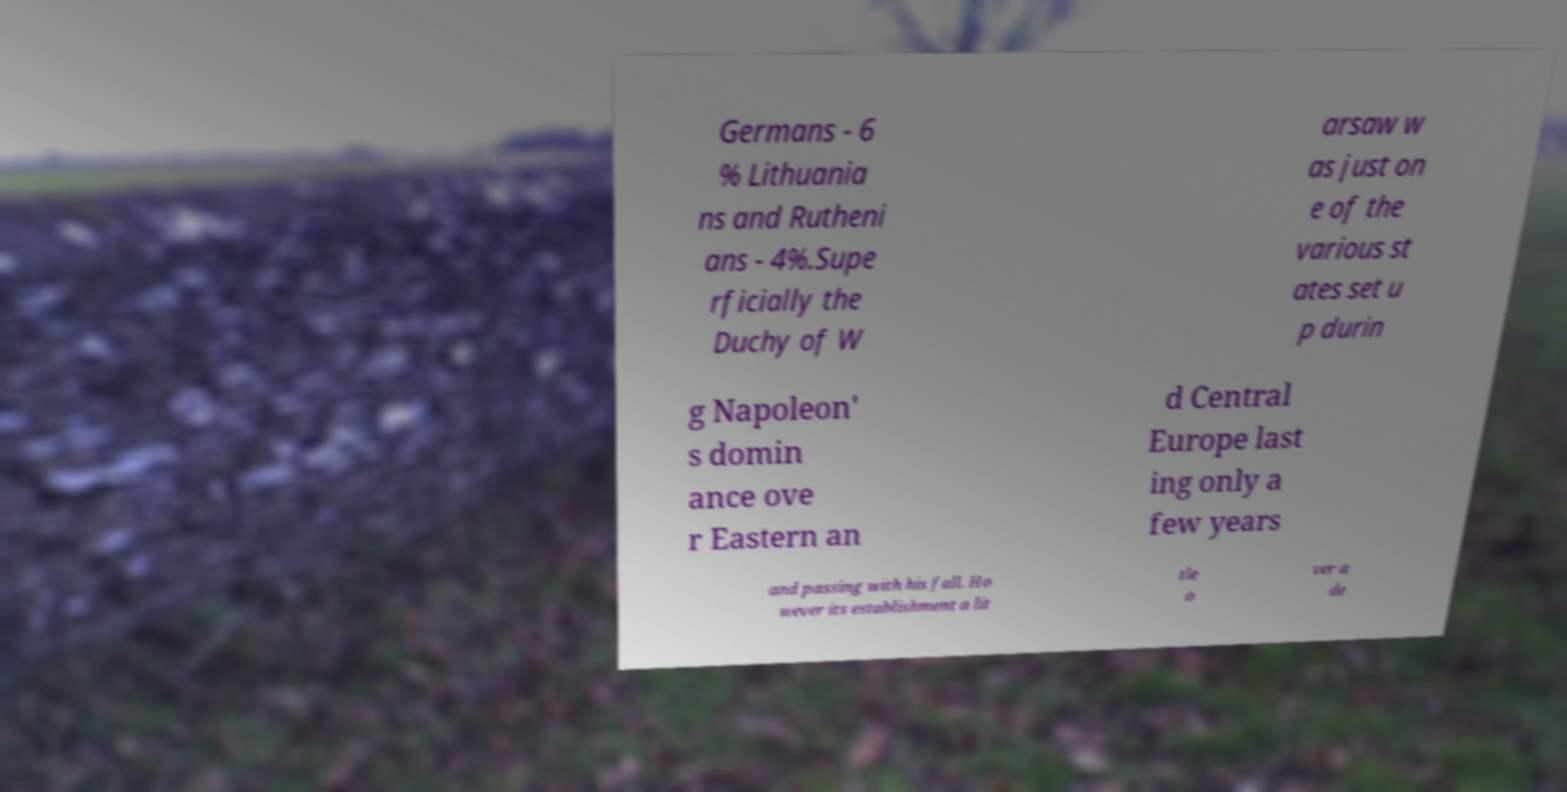Could you extract and type out the text from this image? Germans - 6 % Lithuania ns and Rutheni ans - 4%.Supe rficially the Duchy of W arsaw w as just on e of the various st ates set u p durin g Napoleon' s domin ance ove r Eastern an d Central Europe last ing only a few years and passing with his fall. Ho wever its establishment a lit tle o ver a de 